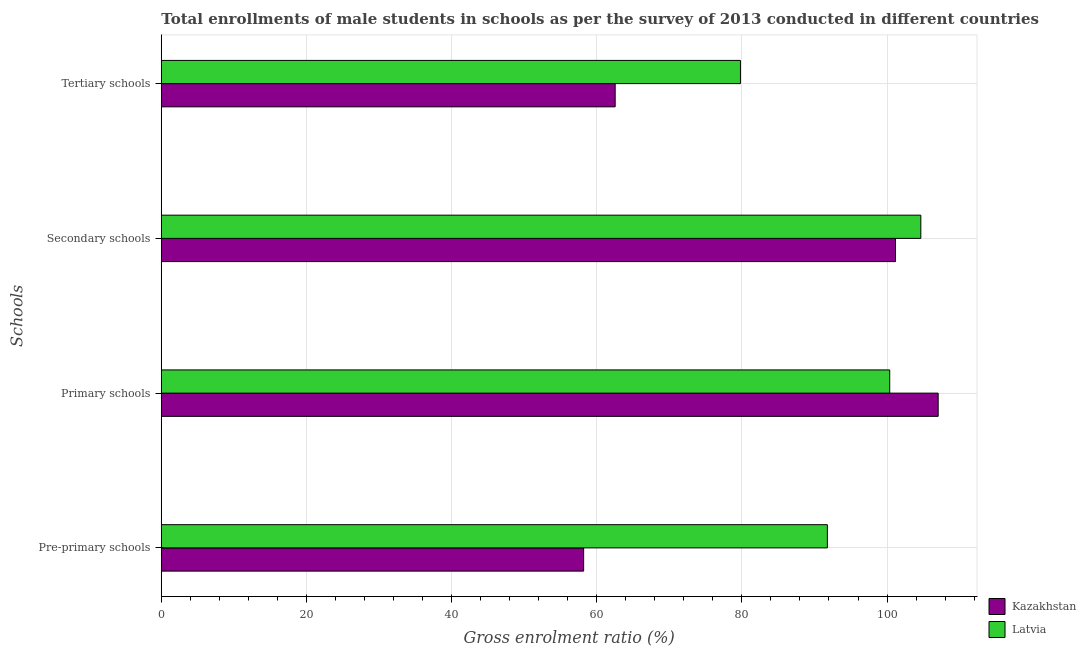How many different coloured bars are there?
Provide a succinct answer. 2. Are the number of bars per tick equal to the number of legend labels?
Keep it short and to the point. Yes. Are the number of bars on each tick of the Y-axis equal?
Your answer should be very brief. Yes. How many bars are there on the 3rd tick from the top?
Your response must be concise. 2. What is the label of the 1st group of bars from the top?
Provide a succinct answer. Tertiary schools. What is the gross enrolment ratio(male) in primary schools in Latvia?
Keep it short and to the point. 100.37. Across all countries, what is the maximum gross enrolment ratio(male) in tertiary schools?
Offer a terse response. 79.8. Across all countries, what is the minimum gross enrolment ratio(male) in secondary schools?
Provide a short and direct response. 101.16. In which country was the gross enrolment ratio(male) in primary schools maximum?
Your answer should be compact. Kazakhstan. In which country was the gross enrolment ratio(male) in secondary schools minimum?
Provide a short and direct response. Kazakhstan. What is the total gross enrolment ratio(male) in tertiary schools in the graph?
Keep it short and to the point. 142.34. What is the difference between the gross enrolment ratio(male) in pre-primary schools in Latvia and that in Kazakhstan?
Your answer should be compact. 33.58. What is the difference between the gross enrolment ratio(male) in tertiary schools in Latvia and the gross enrolment ratio(male) in primary schools in Kazakhstan?
Offer a very short reply. -27.24. What is the average gross enrolment ratio(male) in primary schools per country?
Provide a succinct answer. 103.71. What is the difference between the gross enrolment ratio(male) in secondary schools and gross enrolment ratio(male) in pre-primary schools in Latvia?
Your answer should be compact. 12.88. What is the ratio of the gross enrolment ratio(male) in primary schools in Kazakhstan to that in Latvia?
Provide a succinct answer. 1.07. What is the difference between the highest and the second highest gross enrolment ratio(male) in pre-primary schools?
Provide a short and direct response. 33.58. What is the difference between the highest and the lowest gross enrolment ratio(male) in tertiary schools?
Give a very brief answer. 17.26. In how many countries, is the gross enrolment ratio(male) in pre-primary schools greater than the average gross enrolment ratio(male) in pre-primary schools taken over all countries?
Make the answer very short. 1. What does the 2nd bar from the top in Primary schools represents?
Offer a very short reply. Kazakhstan. What does the 1st bar from the bottom in Tertiary schools represents?
Offer a very short reply. Kazakhstan. Is it the case that in every country, the sum of the gross enrolment ratio(male) in pre-primary schools and gross enrolment ratio(male) in primary schools is greater than the gross enrolment ratio(male) in secondary schools?
Provide a short and direct response. Yes. How many bars are there?
Make the answer very short. 8. Does the graph contain grids?
Ensure brevity in your answer.  Yes. What is the title of the graph?
Make the answer very short. Total enrollments of male students in schools as per the survey of 2013 conducted in different countries. What is the label or title of the X-axis?
Make the answer very short. Gross enrolment ratio (%). What is the label or title of the Y-axis?
Offer a very short reply. Schools. What is the Gross enrolment ratio (%) in Kazakhstan in Pre-primary schools?
Offer a terse response. 58.19. What is the Gross enrolment ratio (%) of Latvia in Pre-primary schools?
Keep it short and to the point. 91.78. What is the Gross enrolment ratio (%) in Kazakhstan in Primary schools?
Make the answer very short. 107.04. What is the Gross enrolment ratio (%) of Latvia in Primary schools?
Your answer should be very brief. 100.37. What is the Gross enrolment ratio (%) in Kazakhstan in Secondary schools?
Offer a terse response. 101.16. What is the Gross enrolment ratio (%) of Latvia in Secondary schools?
Your response must be concise. 104.66. What is the Gross enrolment ratio (%) of Kazakhstan in Tertiary schools?
Your answer should be very brief. 62.54. What is the Gross enrolment ratio (%) of Latvia in Tertiary schools?
Make the answer very short. 79.8. Across all Schools, what is the maximum Gross enrolment ratio (%) of Kazakhstan?
Your answer should be compact. 107.04. Across all Schools, what is the maximum Gross enrolment ratio (%) in Latvia?
Make the answer very short. 104.66. Across all Schools, what is the minimum Gross enrolment ratio (%) of Kazakhstan?
Ensure brevity in your answer.  58.19. Across all Schools, what is the minimum Gross enrolment ratio (%) in Latvia?
Your answer should be very brief. 79.8. What is the total Gross enrolment ratio (%) of Kazakhstan in the graph?
Keep it short and to the point. 328.94. What is the total Gross enrolment ratio (%) of Latvia in the graph?
Your response must be concise. 376.6. What is the difference between the Gross enrolment ratio (%) of Kazakhstan in Pre-primary schools and that in Primary schools?
Your answer should be very brief. -48.85. What is the difference between the Gross enrolment ratio (%) in Latvia in Pre-primary schools and that in Primary schools?
Offer a terse response. -8.59. What is the difference between the Gross enrolment ratio (%) of Kazakhstan in Pre-primary schools and that in Secondary schools?
Provide a succinct answer. -42.97. What is the difference between the Gross enrolment ratio (%) of Latvia in Pre-primary schools and that in Secondary schools?
Your answer should be very brief. -12.88. What is the difference between the Gross enrolment ratio (%) of Kazakhstan in Pre-primary schools and that in Tertiary schools?
Keep it short and to the point. -4.34. What is the difference between the Gross enrolment ratio (%) in Latvia in Pre-primary schools and that in Tertiary schools?
Provide a succinct answer. 11.98. What is the difference between the Gross enrolment ratio (%) in Kazakhstan in Primary schools and that in Secondary schools?
Offer a terse response. 5.88. What is the difference between the Gross enrolment ratio (%) in Latvia in Primary schools and that in Secondary schools?
Your answer should be compact. -4.29. What is the difference between the Gross enrolment ratio (%) of Kazakhstan in Primary schools and that in Tertiary schools?
Ensure brevity in your answer.  44.51. What is the difference between the Gross enrolment ratio (%) in Latvia in Primary schools and that in Tertiary schools?
Keep it short and to the point. 20.57. What is the difference between the Gross enrolment ratio (%) in Kazakhstan in Secondary schools and that in Tertiary schools?
Keep it short and to the point. 38.63. What is the difference between the Gross enrolment ratio (%) of Latvia in Secondary schools and that in Tertiary schools?
Offer a terse response. 24.85. What is the difference between the Gross enrolment ratio (%) in Kazakhstan in Pre-primary schools and the Gross enrolment ratio (%) in Latvia in Primary schools?
Ensure brevity in your answer.  -42.17. What is the difference between the Gross enrolment ratio (%) of Kazakhstan in Pre-primary schools and the Gross enrolment ratio (%) of Latvia in Secondary schools?
Make the answer very short. -46.46. What is the difference between the Gross enrolment ratio (%) in Kazakhstan in Pre-primary schools and the Gross enrolment ratio (%) in Latvia in Tertiary schools?
Your response must be concise. -21.61. What is the difference between the Gross enrolment ratio (%) in Kazakhstan in Primary schools and the Gross enrolment ratio (%) in Latvia in Secondary schools?
Offer a terse response. 2.39. What is the difference between the Gross enrolment ratio (%) in Kazakhstan in Primary schools and the Gross enrolment ratio (%) in Latvia in Tertiary schools?
Your response must be concise. 27.24. What is the difference between the Gross enrolment ratio (%) of Kazakhstan in Secondary schools and the Gross enrolment ratio (%) of Latvia in Tertiary schools?
Provide a short and direct response. 21.36. What is the average Gross enrolment ratio (%) of Kazakhstan per Schools?
Ensure brevity in your answer.  82.23. What is the average Gross enrolment ratio (%) of Latvia per Schools?
Keep it short and to the point. 94.15. What is the difference between the Gross enrolment ratio (%) in Kazakhstan and Gross enrolment ratio (%) in Latvia in Pre-primary schools?
Your answer should be very brief. -33.58. What is the difference between the Gross enrolment ratio (%) of Kazakhstan and Gross enrolment ratio (%) of Latvia in Primary schools?
Provide a succinct answer. 6.68. What is the difference between the Gross enrolment ratio (%) in Kazakhstan and Gross enrolment ratio (%) in Latvia in Secondary schools?
Provide a short and direct response. -3.49. What is the difference between the Gross enrolment ratio (%) in Kazakhstan and Gross enrolment ratio (%) in Latvia in Tertiary schools?
Your answer should be compact. -17.26. What is the ratio of the Gross enrolment ratio (%) in Kazakhstan in Pre-primary schools to that in Primary schools?
Give a very brief answer. 0.54. What is the ratio of the Gross enrolment ratio (%) in Latvia in Pre-primary schools to that in Primary schools?
Keep it short and to the point. 0.91. What is the ratio of the Gross enrolment ratio (%) of Kazakhstan in Pre-primary schools to that in Secondary schools?
Give a very brief answer. 0.58. What is the ratio of the Gross enrolment ratio (%) in Latvia in Pre-primary schools to that in Secondary schools?
Your response must be concise. 0.88. What is the ratio of the Gross enrolment ratio (%) of Kazakhstan in Pre-primary schools to that in Tertiary schools?
Make the answer very short. 0.93. What is the ratio of the Gross enrolment ratio (%) of Latvia in Pre-primary schools to that in Tertiary schools?
Make the answer very short. 1.15. What is the ratio of the Gross enrolment ratio (%) in Kazakhstan in Primary schools to that in Secondary schools?
Ensure brevity in your answer.  1.06. What is the ratio of the Gross enrolment ratio (%) of Kazakhstan in Primary schools to that in Tertiary schools?
Your response must be concise. 1.71. What is the ratio of the Gross enrolment ratio (%) of Latvia in Primary schools to that in Tertiary schools?
Offer a terse response. 1.26. What is the ratio of the Gross enrolment ratio (%) in Kazakhstan in Secondary schools to that in Tertiary schools?
Your answer should be compact. 1.62. What is the ratio of the Gross enrolment ratio (%) of Latvia in Secondary schools to that in Tertiary schools?
Your response must be concise. 1.31. What is the difference between the highest and the second highest Gross enrolment ratio (%) of Kazakhstan?
Your response must be concise. 5.88. What is the difference between the highest and the second highest Gross enrolment ratio (%) of Latvia?
Your answer should be compact. 4.29. What is the difference between the highest and the lowest Gross enrolment ratio (%) of Kazakhstan?
Make the answer very short. 48.85. What is the difference between the highest and the lowest Gross enrolment ratio (%) in Latvia?
Your response must be concise. 24.85. 